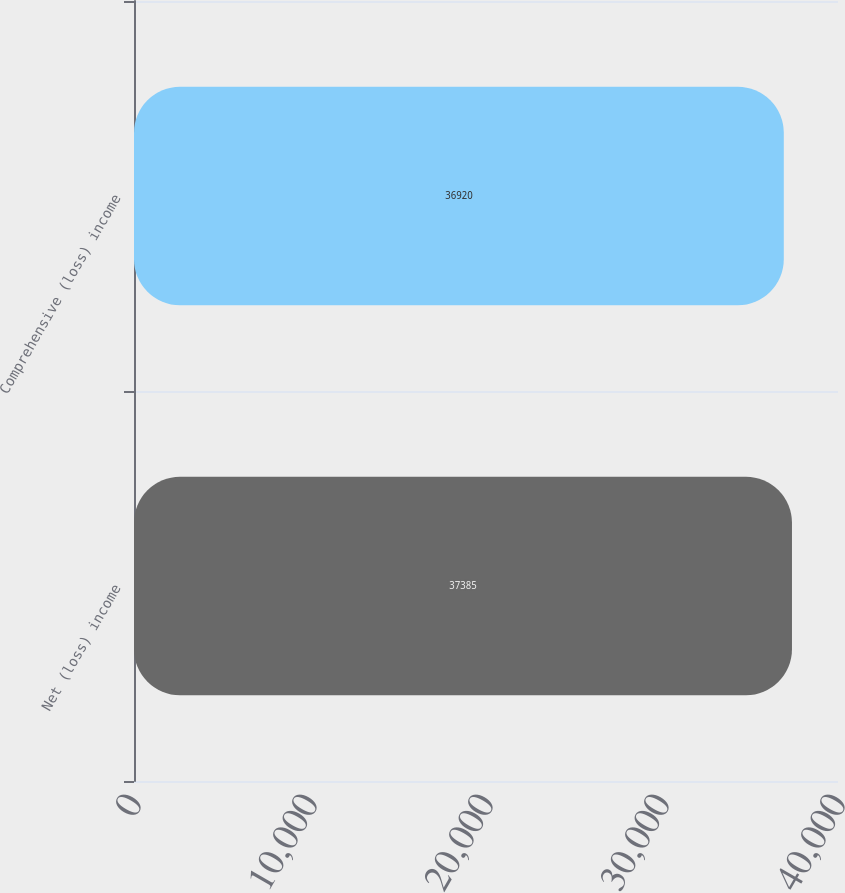Convert chart to OTSL. <chart><loc_0><loc_0><loc_500><loc_500><bar_chart><fcel>Net (loss) income<fcel>Comprehensive (loss) income<nl><fcel>37385<fcel>36920<nl></chart> 